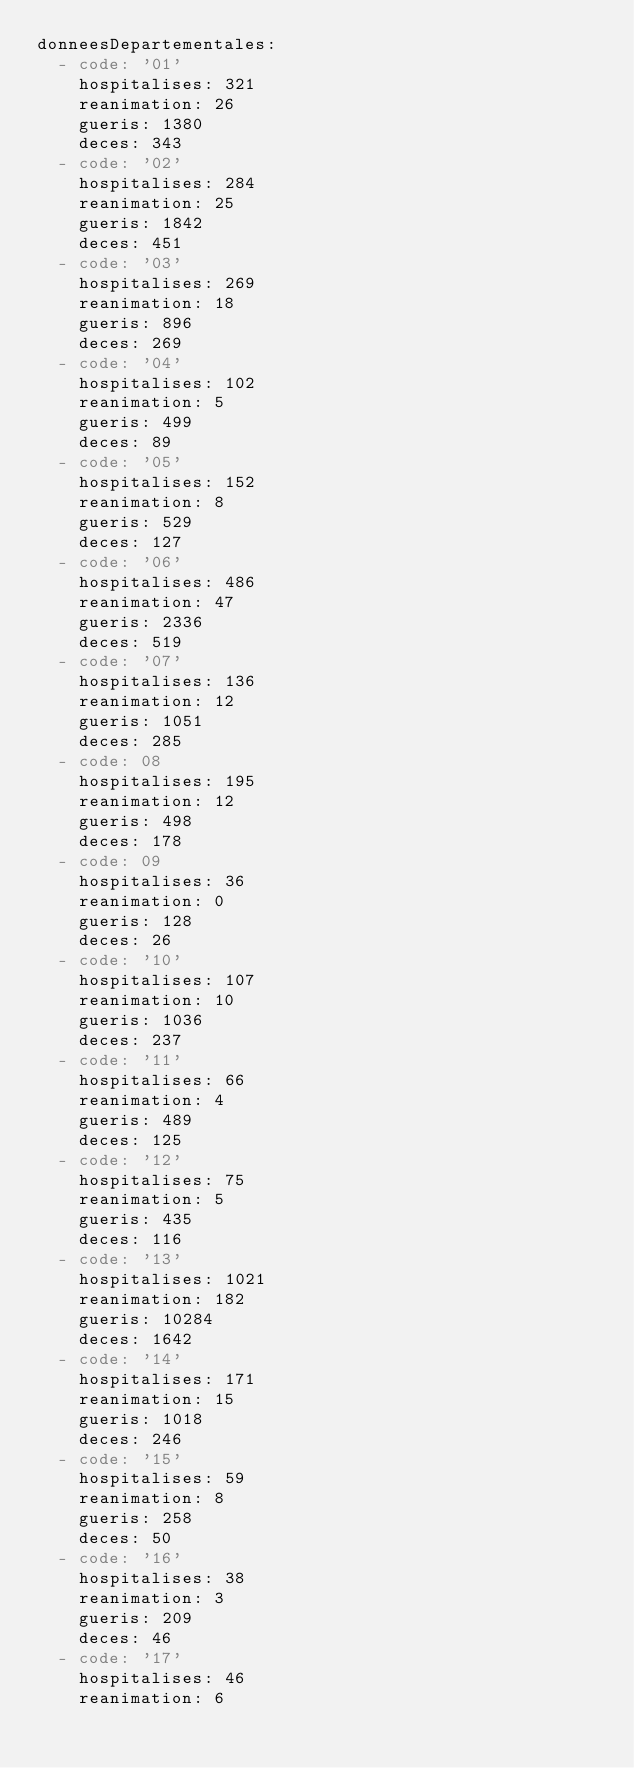<code> <loc_0><loc_0><loc_500><loc_500><_YAML_>donneesDepartementales:
  - code: '01'
    hospitalises: 321
    reanimation: 26
    gueris: 1380
    deces: 343
  - code: '02'
    hospitalises: 284
    reanimation: 25
    gueris: 1842
    deces: 451
  - code: '03'
    hospitalises: 269
    reanimation: 18
    gueris: 896
    deces: 269
  - code: '04'
    hospitalises: 102
    reanimation: 5
    gueris: 499
    deces: 89
  - code: '05'
    hospitalises: 152
    reanimation: 8
    gueris: 529
    deces: 127
  - code: '06'
    hospitalises: 486
    reanimation: 47
    gueris: 2336
    deces: 519
  - code: '07'
    hospitalises: 136
    reanimation: 12
    gueris: 1051
    deces: 285
  - code: 08
    hospitalises: 195
    reanimation: 12
    gueris: 498
    deces: 178
  - code: 09
    hospitalises: 36
    reanimation: 0
    gueris: 128
    deces: 26
  - code: '10'
    hospitalises: 107
    reanimation: 10
    gueris: 1036
    deces: 237
  - code: '11'
    hospitalises: 66
    reanimation: 4
    gueris: 489
    deces: 125
  - code: '12'
    hospitalises: 75
    reanimation: 5
    gueris: 435
    deces: 116
  - code: '13'
    hospitalises: 1021
    reanimation: 182
    gueris: 10284
    deces: 1642
  - code: '14'
    hospitalises: 171
    reanimation: 15
    gueris: 1018
    deces: 246
  - code: '15'
    hospitalises: 59
    reanimation: 8
    gueris: 258
    deces: 50
  - code: '16'
    hospitalises: 38
    reanimation: 3
    gueris: 209
    deces: 46
  - code: '17'
    hospitalises: 46
    reanimation: 6</code> 